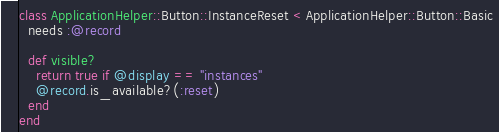Convert code to text. <code><loc_0><loc_0><loc_500><loc_500><_Ruby_>class ApplicationHelper::Button::InstanceReset < ApplicationHelper::Button::Basic
  needs :@record

  def visible?
    return true if @display == "instances"
    @record.is_available?(:reset)
  end
end
</code> 